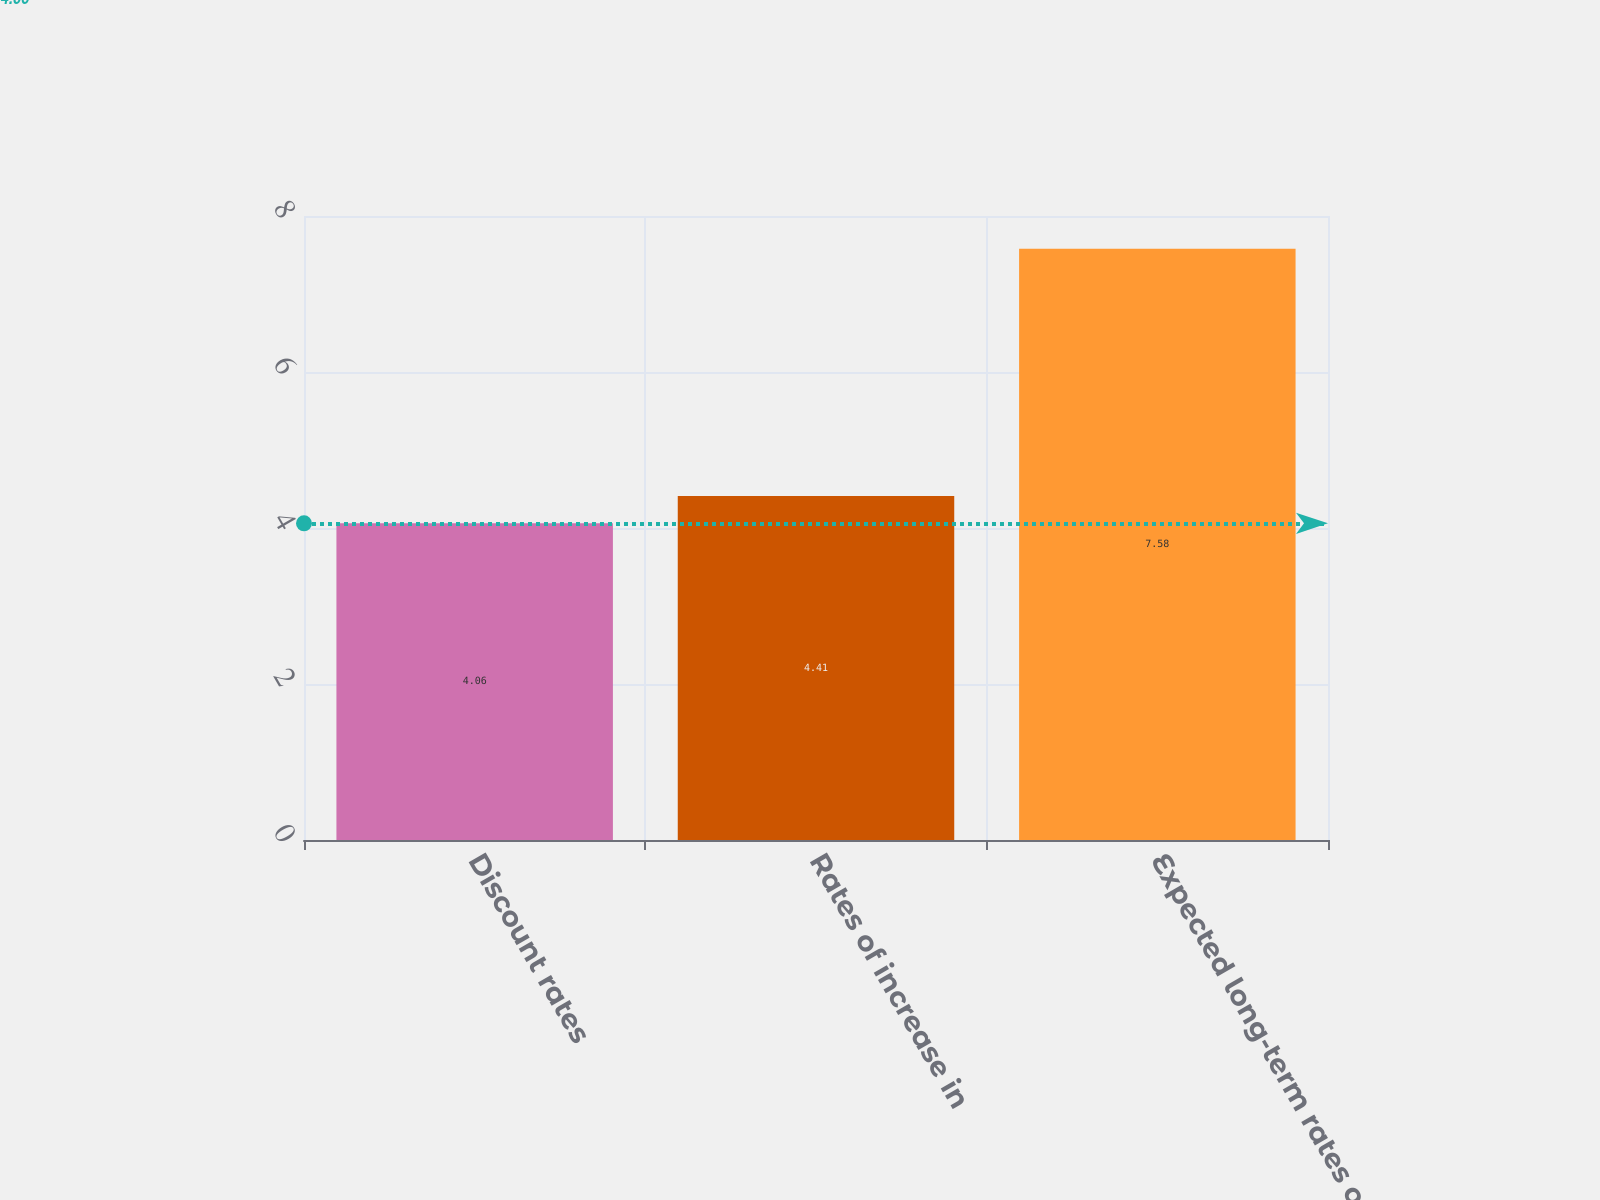<chart> <loc_0><loc_0><loc_500><loc_500><bar_chart><fcel>Discount rates<fcel>Rates of increase in<fcel>Expected long-term rates of<nl><fcel>4.06<fcel>4.41<fcel>7.58<nl></chart> 